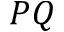Convert formula to latex. <formula><loc_0><loc_0><loc_500><loc_500>P Q</formula> 